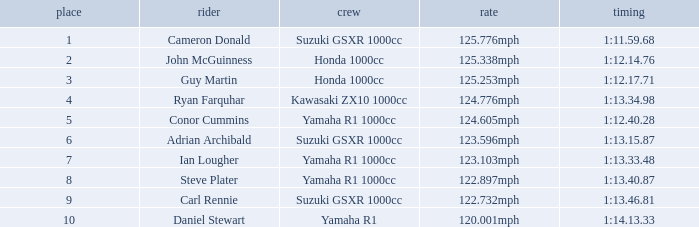What is the rank for the team with a Time of 1:12.40.28? 5.0. 